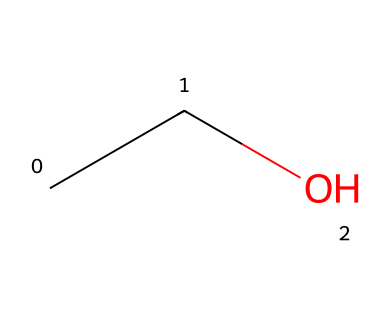What is the main alcohol present in communion wine? The SMILES representation shows "CCO", which corresponds to ethanol, the primary alcohol found in communion wine.
Answer: ethanol How many carbon atoms are present in this compound? The structure represented by the SMILES contains two carbon atoms (C), as indicated by the two "C" characters at the beginning.
Answer: 2 How many oxygen atoms are in this molecule? The structure indicates one oxygen atom (O), which appears as "O" in the SMILES notation after the carbon chain.
Answer: 1 What is the general formula for this type of alcohol? The structure "C2H6O" corresponds to the formula for ethanol, an alcohol with one hydroxyl (-OH) functional group.
Answer: C2H6O Is this compound considered an oxidizer? Ethanol itself is not classified as an oxidizer; oxidizers generally have more reactive properties involving oxygen in their structure.
Answer: no What functional group is present in this molecule? The presence of the "O" in the structure indicates that this molecule has a hydroxyl functional group (-OH) typical of alcohols.
Answer: hydroxyl Can this compound undergo oxidation? Yes, ethanol can undergo oxidation to form acetaldehyde and then further oxidize to acetic acid, indicating it is capable of oxidation reactions.
Answer: yes 